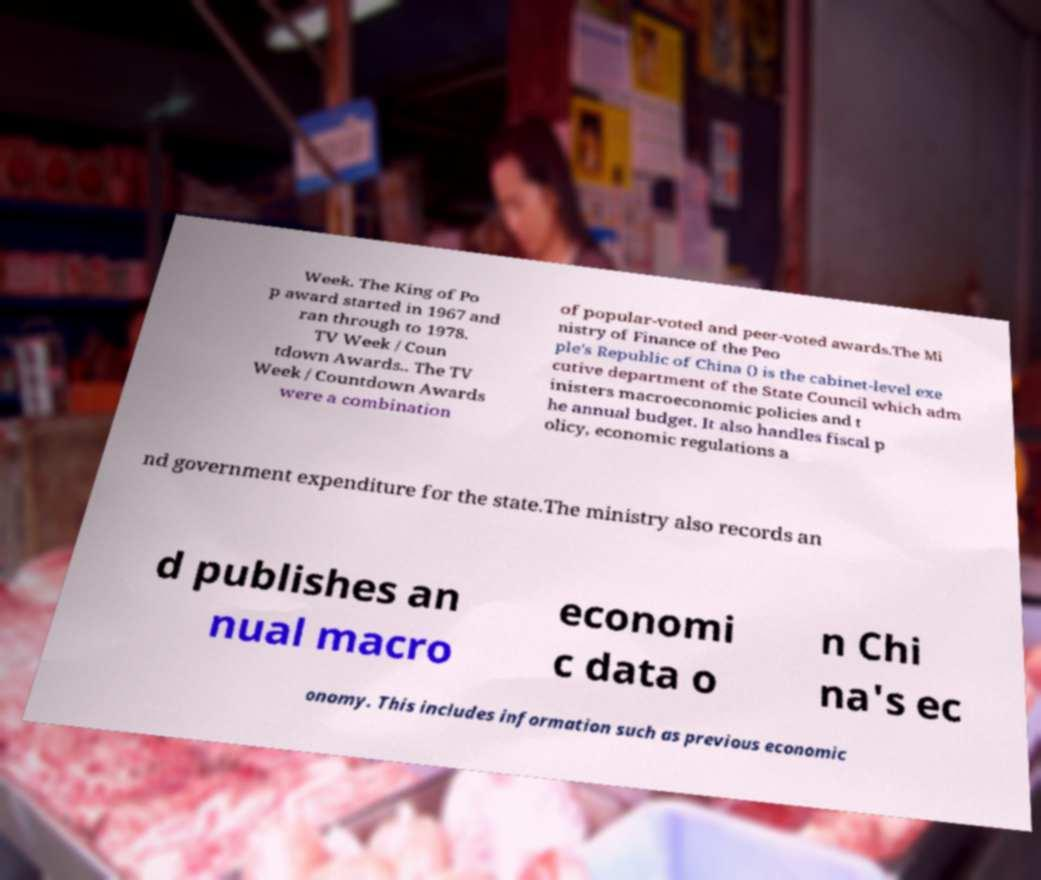Please read and relay the text visible in this image. What does it say? Week. The King of Po p award started in 1967 and ran through to 1978. TV Week / Coun tdown Awards.. The TV Week / Countdown Awards were a combination of popular-voted and peer-voted awards.The Mi nistry of Finance of the Peo ple's Republic of China () is the cabinet-level exe cutive department of the State Council which adm inisters macroeconomic policies and t he annual budget. It also handles fiscal p olicy, economic regulations a nd government expenditure for the state.The ministry also records an d publishes an nual macro economi c data o n Chi na's ec onomy. This includes information such as previous economic 